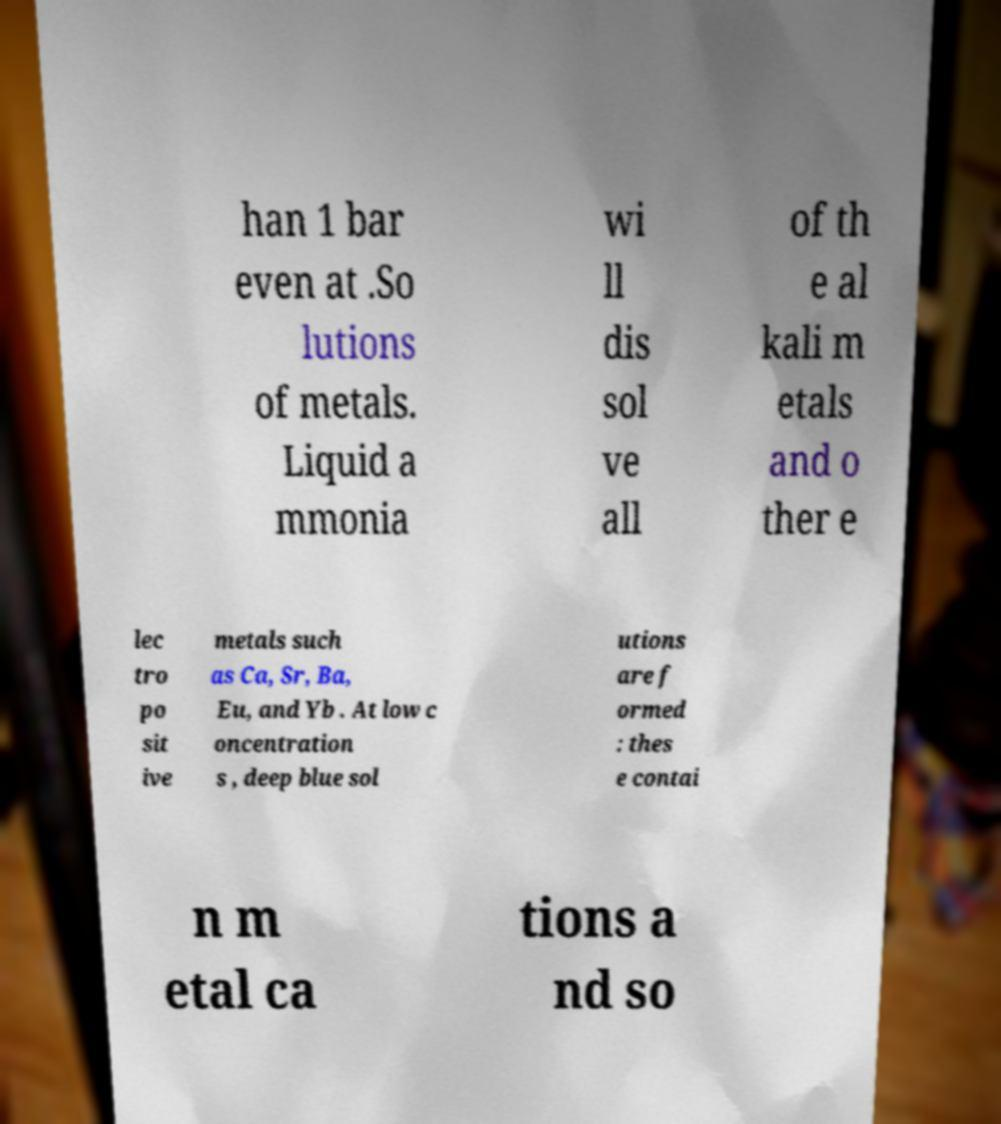There's text embedded in this image that I need extracted. Can you transcribe it verbatim? han 1 bar even at .So lutions of metals. Liquid a mmonia wi ll dis sol ve all of th e al kali m etals and o ther e lec tro po sit ive metals such as Ca, Sr, Ba, Eu, and Yb . At low c oncentration s , deep blue sol utions are f ormed : thes e contai n m etal ca tions a nd so 